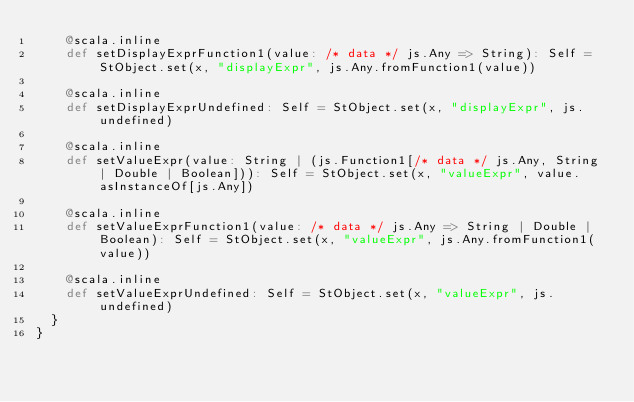Convert code to text. <code><loc_0><loc_0><loc_500><loc_500><_Scala_>    @scala.inline
    def setDisplayExprFunction1(value: /* data */ js.Any => String): Self = StObject.set(x, "displayExpr", js.Any.fromFunction1(value))
    
    @scala.inline
    def setDisplayExprUndefined: Self = StObject.set(x, "displayExpr", js.undefined)
    
    @scala.inline
    def setValueExpr(value: String | (js.Function1[/* data */ js.Any, String | Double | Boolean])): Self = StObject.set(x, "valueExpr", value.asInstanceOf[js.Any])
    
    @scala.inline
    def setValueExprFunction1(value: /* data */ js.Any => String | Double | Boolean): Self = StObject.set(x, "valueExpr", js.Any.fromFunction1(value))
    
    @scala.inline
    def setValueExprUndefined: Self = StObject.set(x, "valueExpr", js.undefined)
  }
}
</code> 